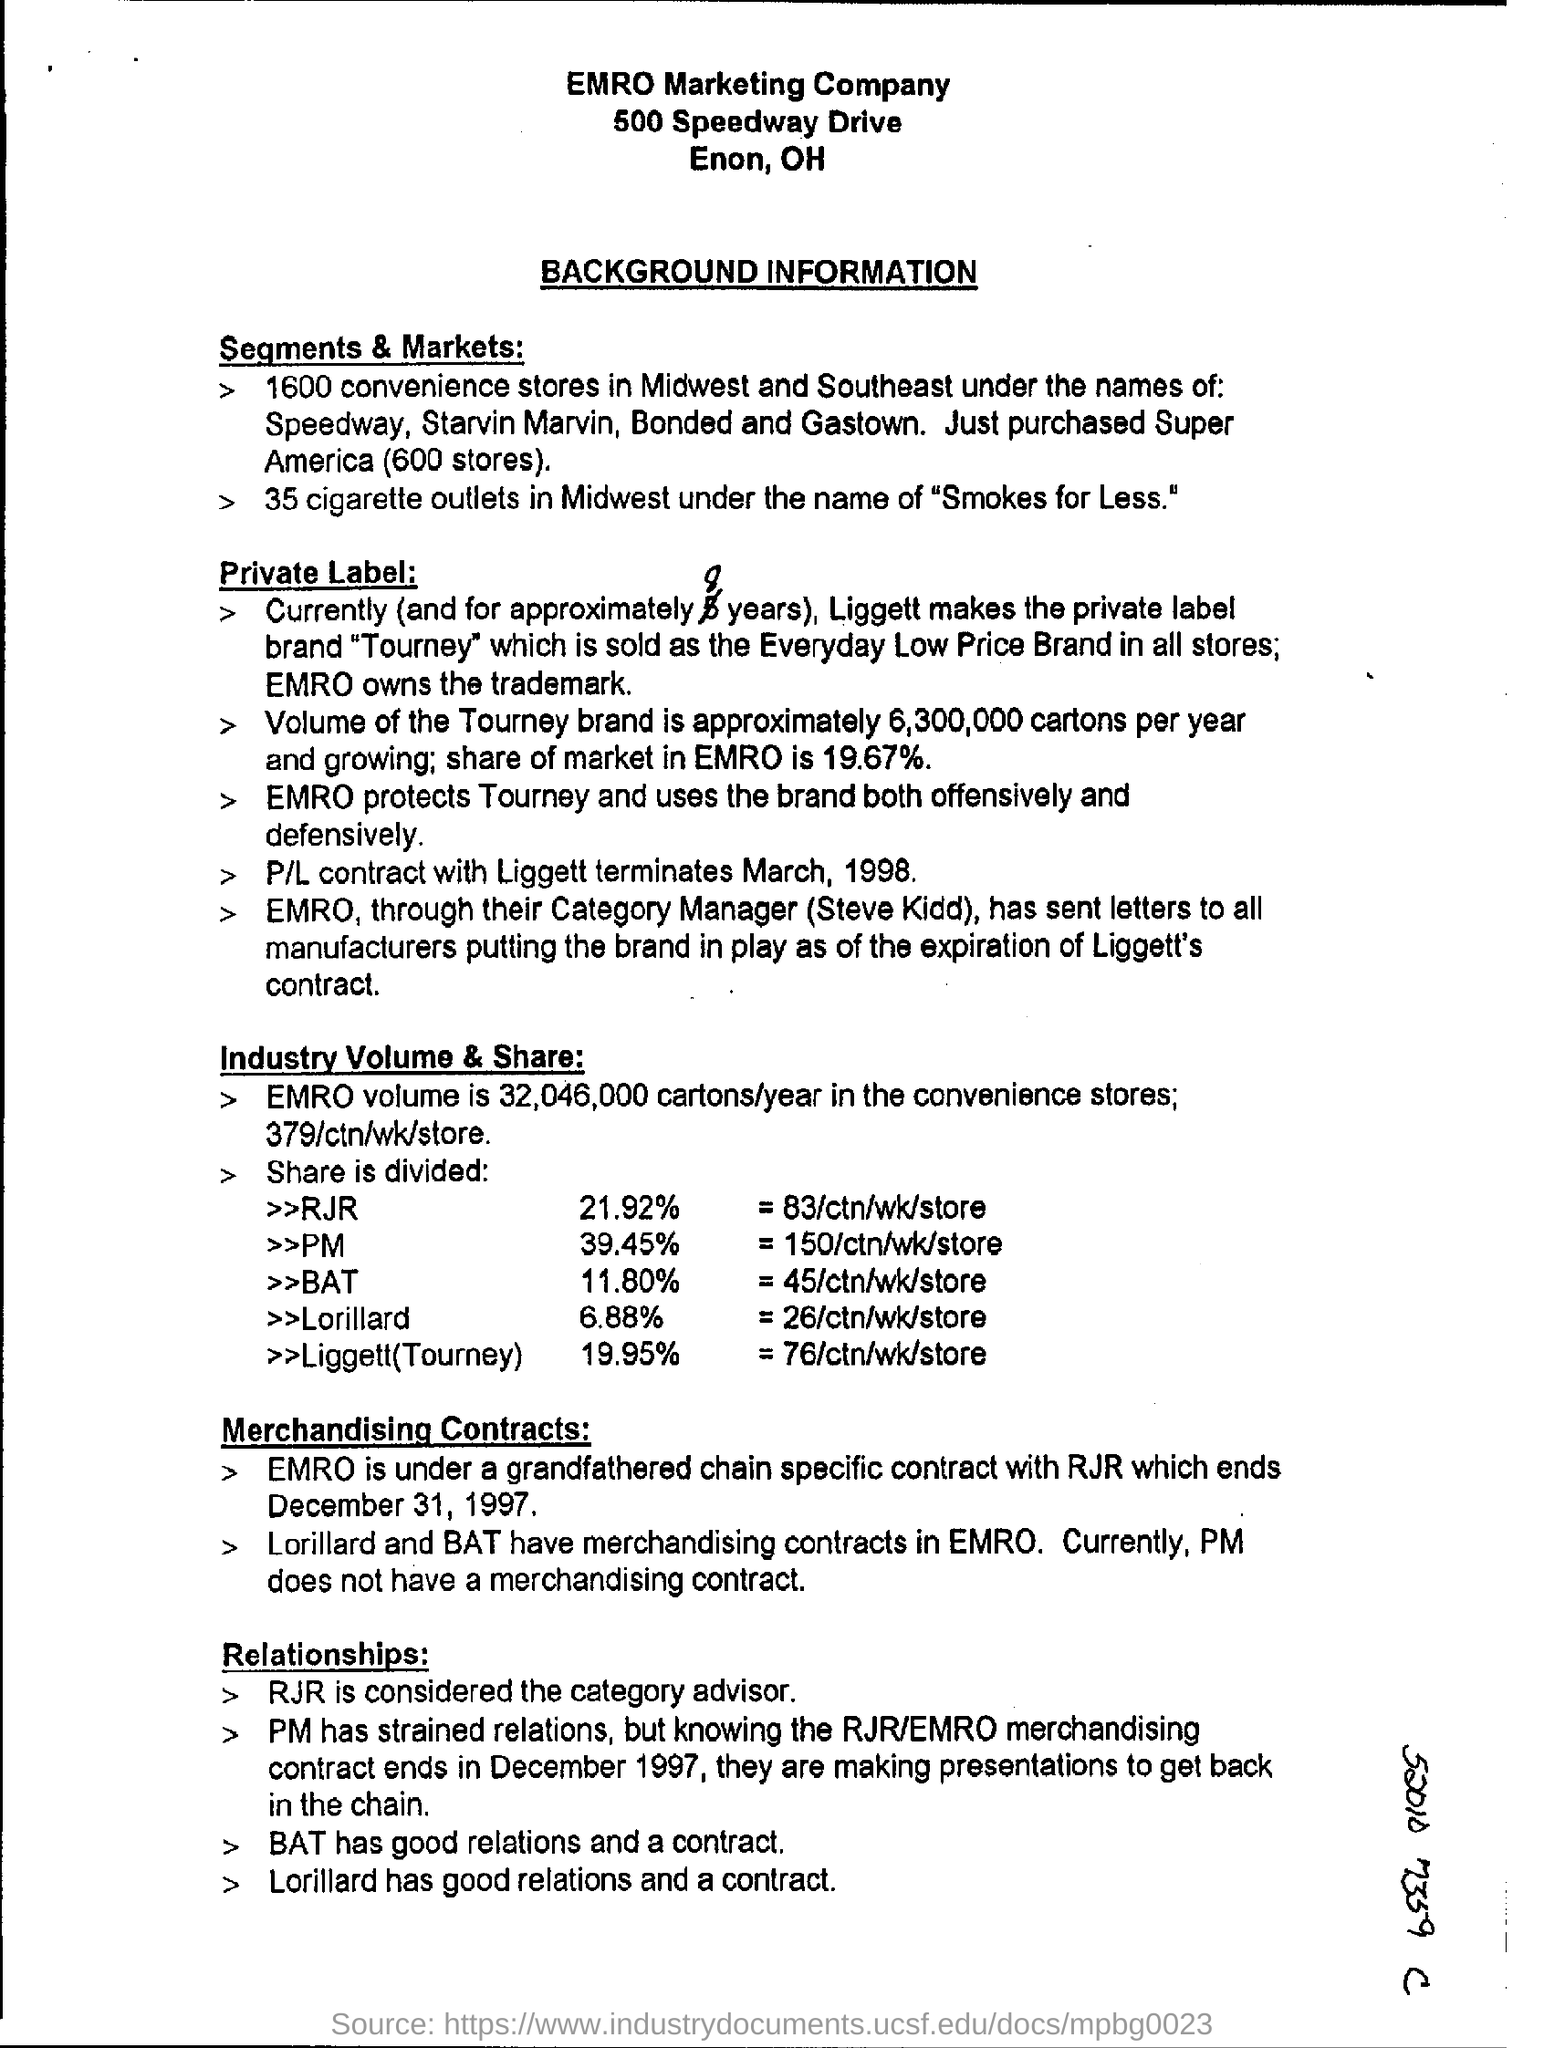Specify some key components in this picture. There are 35 cigarette outlets located in the Midwest region, according to the "Segments & Markets" section of the document. Based on the sub-heading "Relationships:", who is considered to be in the category advisor role? There are approximately 1,600 convenience stores in the Midwest and Southeast regions of the United States. According to the information provided under "Industry Volume & Share," RJR holds a share of 21.92% in the industry. The document outlines background information of a particular type. 